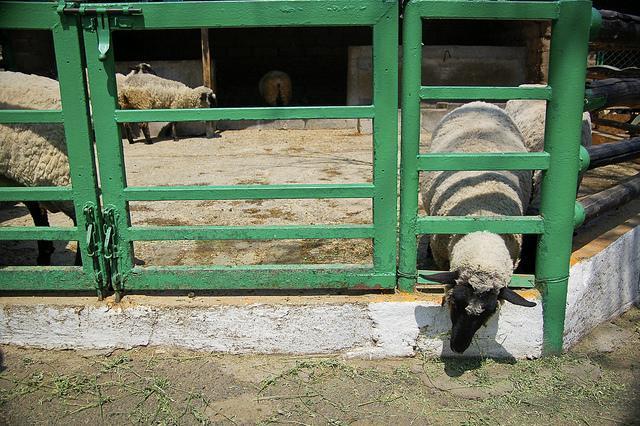How many sheep are visible?
Give a very brief answer. 4. 